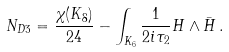<formula> <loc_0><loc_0><loc_500><loc_500>N _ { D 3 } = \frac { \chi ( K _ { 8 } ) } { 2 4 } - \int _ { K _ { 6 } } \frac { 1 } { 2 i \tau _ { 2 } } H \wedge { \bar { H } } \, .</formula> 